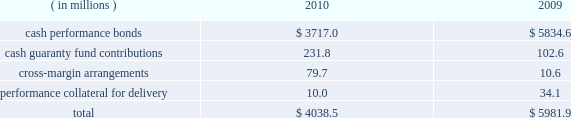Anticipated or possible short-term cash needs , prevailing interest rates , our investment policy and alternative investment choices .
A majority of our cash and cash equivalents balance is invested in money market mutual funds that invest only in u.s .
Treasury securities or u.s .
Government agency securities .
Our exposure to risk is minimal given the nature of the investments .
Our practice is to have our pension plan 100% ( 100 % ) funded at each year end on a projected benefit obligation basis , while also satisfying any minimum required contribution and obtaining the maximum tax deduction .
Based on our actuarial projections , we estimate that a $ 14.1 million contribution in 2011 will allow us to meet our funding goal .
However , the amount of the actual contribution is contingent on the actual rate of return on our plan assets during 2011 and the december 31 , 2011 discount rate .
Net current deferred tax assets of $ 18.3 million and $ 23.8 million are included in other current assets at december 31 , 2010 and 2009 , respectively .
Total net current deferred tax assets include unrealized losses , stock- based compensation and accrued expenses .
Net long-term deferred tax liabilities were $ 7.8 billion and $ 7.6 billion at december 31 , 2010 and 2009 , respectively .
Net deferred tax liabilities are principally the result of purchase accounting for intangible assets in our various mergers including cbot holdings and nymex holdings .
We have a long-term deferred tax asset of $ 145.7 million included within our domestic long-term deferred tax liability .
This deferred tax asset is for an unrealized capital loss incurred in brazil related to our investment in bm&fbovespa .
As of december 31 , 2010 , we do not believe that we currently meet the more-likely-than-not threshold that would allow us to fully realize the value of the unrealized capital loss .
As a result , a partial valuation allowance of $ 64.4 million has been provided for the amount of the unrealized capital loss that exceeds potential capital gains that could be used to offset the capital loss in future periods .
We also have a long-term deferred tax asset related to brazilian taxes of $ 125.3 million for an unrealized capital loss incurred in brazil related to our investment in bm&fbovespa .
A full valuation allowance of $ 125.3 million has been provided because we do not believe that we currently meet the more-likely-than-not threshold that would allow us to realize the value of the unrealized capital loss in brazil in the future .
Valuation allowances of $ 49.4 million have also been provided for additional unrealized capital losses on various other investments .
Net long-term deferred tax assets also include a $ 19.3 million deferred tax asset for foreign net operating losses related to swapstream .
Our assessment at december 31 , 2010 was that we did not currently meet the more-likely- than-not threshold that would allow us to realize the value of acquired and accumulated foreign net operating losses in the future .
As a result , the $ 19.3 million deferred tax assets arising from these net operating losses have been fully reserved .
Each clearing firm is required to deposit and maintain specified performance bond collateral .
Performance bond requirements are determined by parameters established by the risk management department of the clearing house and may fluctuate over time .
We accept a variety of collateral to satisfy performance bond requirements .
Cash performance bonds and guaranty fund contributions are included in our consolidated balance sheets .
Clearing firm deposits , other than those retained in the form of cash , are not included in our consolidated balance sheets .
The balances in cash performance bonds and guaranty fund contributions may fluctuate significantly over time .
Cash performance bonds and guaranty fund contributions consisted of the following at december 31: .

What is the decrease of the cash perfomance bonds in the years of 2009 and 2010 in millions? 
Rationale: its the difference between those two values , in millions .
Computations: (3717.0 - 5834.6)
Answer: -2117.6. 